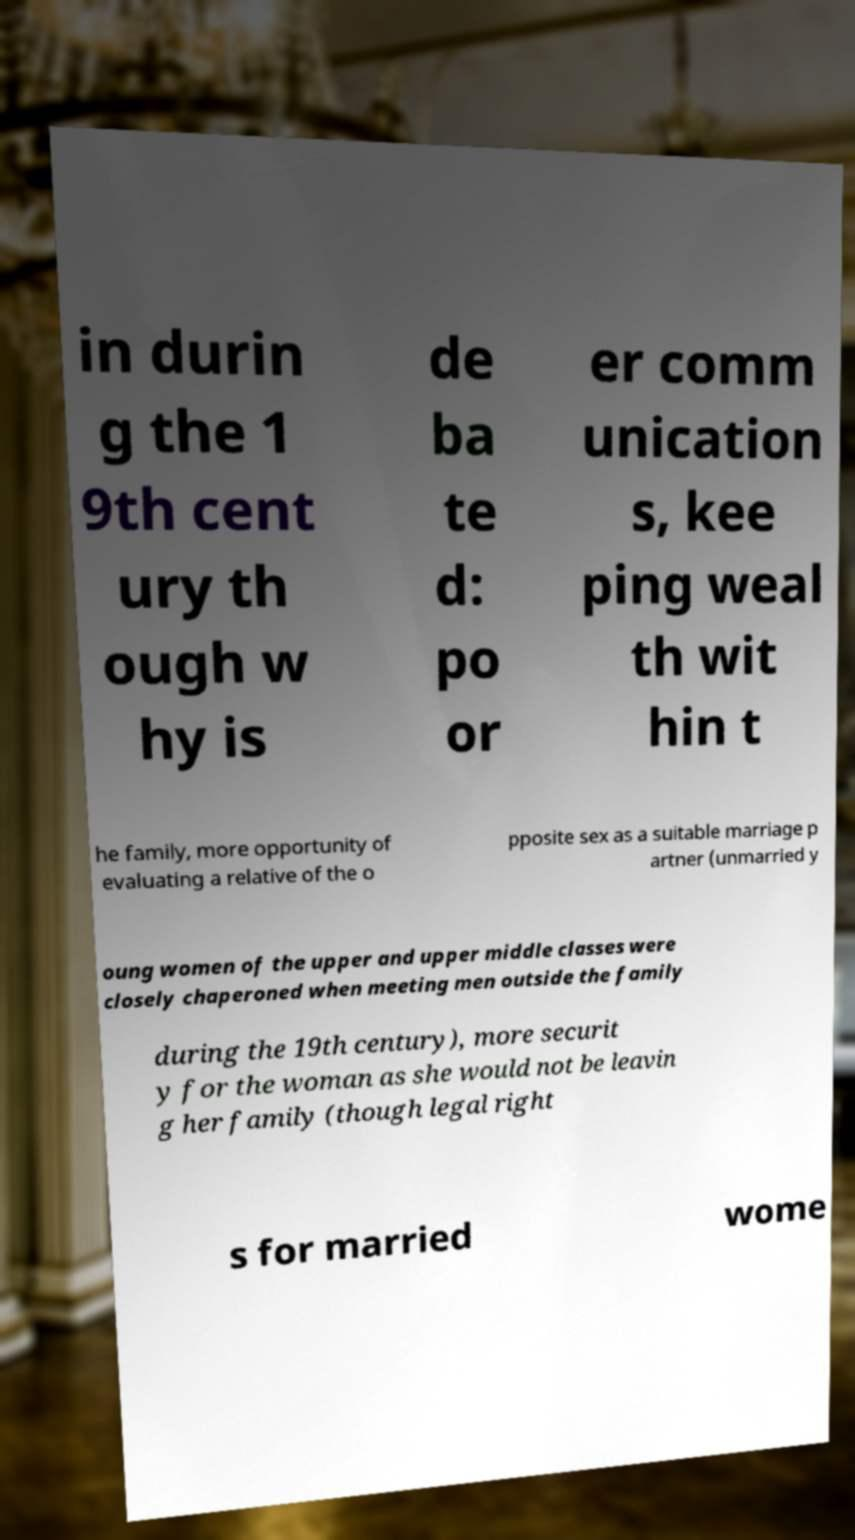Could you assist in decoding the text presented in this image and type it out clearly? in durin g the 1 9th cent ury th ough w hy is de ba te d: po or er comm unication s, kee ping weal th wit hin t he family, more opportunity of evaluating a relative of the o pposite sex as a suitable marriage p artner (unmarried y oung women of the upper and upper middle classes were closely chaperoned when meeting men outside the family during the 19th century), more securit y for the woman as she would not be leavin g her family (though legal right s for married wome 